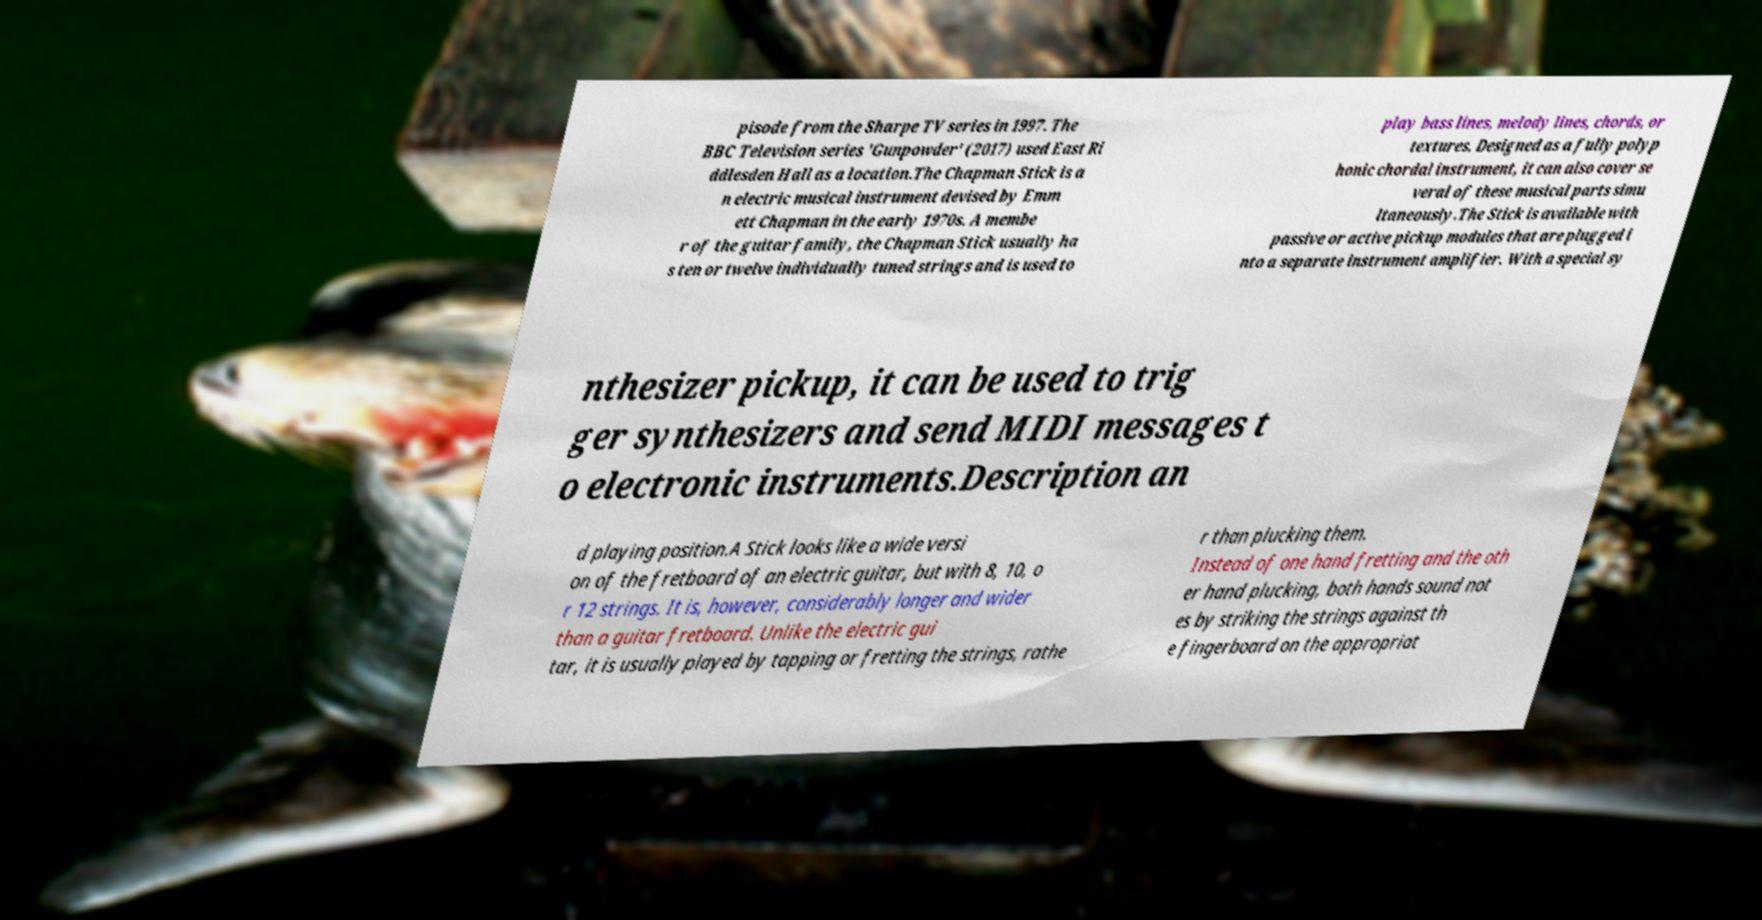Please identify and transcribe the text found in this image. pisode from the Sharpe TV series in 1997. The BBC Television series 'Gunpowder' (2017) used East Ri ddlesden Hall as a location.The Chapman Stick is a n electric musical instrument devised by Emm ett Chapman in the early 1970s. A membe r of the guitar family, the Chapman Stick usually ha s ten or twelve individually tuned strings and is used to play bass lines, melody lines, chords, or textures. Designed as a fully polyp honic chordal instrument, it can also cover se veral of these musical parts simu ltaneously.The Stick is available with passive or active pickup modules that are plugged i nto a separate instrument amplifier. With a special sy nthesizer pickup, it can be used to trig ger synthesizers and send MIDI messages t o electronic instruments.Description an d playing position.A Stick looks like a wide versi on of the fretboard of an electric guitar, but with 8, 10, o r 12 strings. It is, however, considerably longer and wider than a guitar fretboard. Unlike the electric gui tar, it is usually played by tapping or fretting the strings, rathe r than plucking them. Instead of one hand fretting and the oth er hand plucking, both hands sound not es by striking the strings against th e fingerboard on the appropriat 